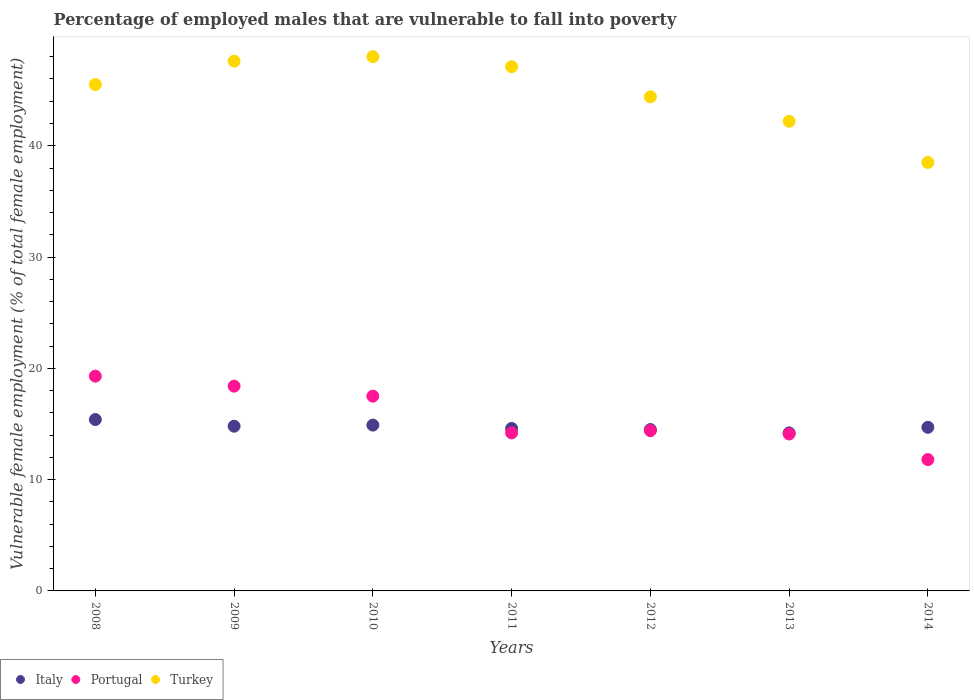What is the percentage of employed males who are vulnerable to fall into poverty in Portugal in 2013?
Give a very brief answer. 14.1. Across all years, what is the maximum percentage of employed males who are vulnerable to fall into poverty in Italy?
Provide a short and direct response. 15.4. Across all years, what is the minimum percentage of employed males who are vulnerable to fall into poverty in Turkey?
Your answer should be very brief. 38.5. What is the total percentage of employed males who are vulnerable to fall into poverty in Italy in the graph?
Your answer should be very brief. 103.1. What is the difference between the percentage of employed males who are vulnerable to fall into poverty in Portugal in 2009 and that in 2014?
Your answer should be very brief. 6.6. What is the difference between the percentage of employed males who are vulnerable to fall into poverty in Turkey in 2014 and the percentage of employed males who are vulnerable to fall into poverty in Italy in 2009?
Ensure brevity in your answer.  23.7. What is the average percentage of employed males who are vulnerable to fall into poverty in Turkey per year?
Provide a succinct answer. 44.76. In the year 2008, what is the difference between the percentage of employed males who are vulnerable to fall into poverty in Italy and percentage of employed males who are vulnerable to fall into poverty in Turkey?
Offer a terse response. -30.1. In how many years, is the percentage of employed males who are vulnerable to fall into poverty in Turkey greater than 20 %?
Keep it short and to the point. 7. What is the ratio of the percentage of employed males who are vulnerable to fall into poverty in Italy in 2010 to that in 2014?
Offer a very short reply. 1.01. What is the difference between the highest and the second highest percentage of employed males who are vulnerable to fall into poverty in Italy?
Keep it short and to the point. 0.5. What is the difference between the highest and the lowest percentage of employed males who are vulnerable to fall into poverty in Italy?
Ensure brevity in your answer.  1.2. Is the percentage of employed males who are vulnerable to fall into poverty in Italy strictly less than the percentage of employed males who are vulnerable to fall into poverty in Turkey over the years?
Offer a terse response. Yes. How many dotlines are there?
Provide a short and direct response. 3. How many years are there in the graph?
Ensure brevity in your answer.  7. What is the difference between two consecutive major ticks on the Y-axis?
Ensure brevity in your answer.  10. Does the graph contain any zero values?
Provide a short and direct response. No. How are the legend labels stacked?
Provide a succinct answer. Horizontal. What is the title of the graph?
Ensure brevity in your answer.  Percentage of employed males that are vulnerable to fall into poverty. Does "Zambia" appear as one of the legend labels in the graph?
Your answer should be compact. No. What is the label or title of the Y-axis?
Your answer should be compact. Vulnerable female employment (% of total female employment). What is the Vulnerable female employment (% of total female employment) in Italy in 2008?
Provide a short and direct response. 15.4. What is the Vulnerable female employment (% of total female employment) of Portugal in 2008?
Your answer should be very brief. 19.3. What is the Vulnerable female employment (% of total female employment) of Turkey in 2008?
Your answer should be compact. 45.5. What is the Vulnerable female employment (% of total female employment) in Italy in 2009?
Give a very brief answer. 14.8. What is the Vulnerable female employment (% of total female employment) in Portugal in 2009?
Give a very brief answer. 18.4. What is the Vulnerable female employment (% of total female employment) in Turkey in 2009?
Offer a very short reply. 47.6. What is the Vulnerable female employment (% of total female employment) of Italy in 2010?
Make the answer very short. 14.9. What is the Vulnerable female employment (% of total female employment) in Portugal in 2010?
Your answer should be compact. 17.5. What is the Vulnerable female employment (% of total female employment) in Italy in 2011?
Give a very brief answer. 14.6. What is the Vulnerable female employment (% of total female employment) of Portugal in 2011?
Offer a very short reply. 14.2. What is the Vulnerable female employment (% of total female employment) of Turkey in 2011?
Offer a terse response. 47.1. What is the Vulnerable female employment (% of total female employment) in Italy in 2012?
Offer a very short reply. 14.5. What is the Vulnerable female employment (% of total female employment) of Portugal in 2012?
Provide a succinct answer. 14.4. What is the Vulnerable female employment (% of total female employment) of Turkey in 2012?
Give a very brief answer. 44.4. What is the Vulnerable female employment (% of total female employment) in Italy in 2013?
Offer a very short reply. 14.2. What is the Vulnerable female employment (% of total female employment) in Portugal in 2013?
Keep it short and to the point. 14.1. What is the Vulnerable female employment (% of total female employment) of Turkey in 2013?
Make the answer very short. 42.2. What is the Vulnerable female employment (% of total female employment) of Italy in 2014?
Provide a succinct answer. 14.7. What is the Vulnerable female employment (% of total female employment) in Portugal in 2014?
Your response must be concise. 11.8. What is the Vulnerable female employment (% of total female employment) of Turkey in 2014?
Provide a succinct answer. 38.5. Across all years, what is the maximum Vulnerable female employment (% of total female employment) in Italy?
Offer a terse response. 15.4. Across all years, what is the maximum Vulnerable female employment (% of total female employment) of Portugal?
Provide a short and direct response. 19.3. Across all years, what is the minimum Vulnerable female employment (% of total female employment) of Italy?
Offer a very short reply. 14.2. Across all years, what is the minimum Vulnerable female employment (% of total female employment) in Portugal?
Keep it short and to the point. 11.8. Across all years, what is the minimum Vulnerable female employment (% of total female employment) in Turkey?
Your answer should be compact. 38.5. What is the total Vulnerable female employment (% of total female employment) in Italy in the graph?
Your answer should be very brief. 103.1. What is the total Vulnerable female employment (% of total female employment) of Portugal in the graph?
Offer a terse response. 109.7. What is the total Vulnerable female employment (% of total female employment) of Turkey in the graph?
Offer a very short reply. 313.3. What is the difference between the Vulnerable female employment (% of total female employment) of Italy in 2008 and that in 2009?
Give a very brief answer. 0.6. What is the difference between the Vulnerable female employment (% of total female employment) of Turkey in 2008 and that in 2009?
Offer a terse response. -2.1. What is the difference between the Vulnerable female employment (% of total female employment) in Italy in 2008 and that in 2010?
Offer a very short reply. 0.5. What is the difference between the Vulnerable female employment (% of total female employment) in Portugal in 2008 and that in 2010?
Your answer should be very brief. 1.8. What is the difference between the Vulnerable female employment (% of total female employment) in Turkey in 2008 and that in 2011?
Make the answer very short. -1.6. What is the difference between the Vulnerable female employment (% of total female employment) of Italy in 2008 and that in 2012?
Offer a terse response. 0.9. What is the difference between the Vulnerable female employment (% of total female employment) of Portugal in 2008 and that in 2012?
Your answer should be very brief. 4.9. What is the difference between the Vulnerable female employment (% of total female employment) of Turkey in 2008 and that in 2012?
Make the answer very short. 1.1. What is the difference between the Vulnerable female employment (% of total female employment) of Italy in 2008 and that in 2013?
Provide a short and direct response. 1.2. What is the difference between the Vulnerable female employment (% of total female employment) of Turkey in 2008 and that in 2013?
Provide a succinct answer. 3.3. What is the difference between the Vulnerable female employment (% of total female employment) of Portugal in 2008 and that in 2014?
Provide a succinct answer. 7.5. What is the difference between the Vulnerable female employment (% of total female employment) in Turkey in 2008 and that in 2014?
Your answer should be compact. 7. What is the difference between the Vulnerable female employment (% of total female employment) in Italy in 2009 and that in 2010?
Give a very brief answer. -0.1. What is the difference between the Vulnerable female employment (% of total female employment) of Portugal in 2009 and that in 2010?
Your response must be concise. 0.9. What is the difference between the Vulnerable female employment (% of total female employment) of Turkey in 2009 and that in 2011?
Provide a succinct answer. 0.5. What is the difference between the Vulnerable female employment (% of total female employment) in Turkey in 2009 and that in 2012?
Provide a short and direct response. 3.2. What is the difference between the Vulnerable female employment (% of total female employment) of Portugal in 2009 and that in 2013?
Provide a short and direct response. 4.3. What is the difference between the Vulnerable female employment (% of total female employment) in Turkey in 2009 and that in 2013?
Offer a very short reply. 5.4. What is the difference between the Vulnerable female employment (% of total female employment) of Italy in 2009 and that in 2014?
Make the answer very short. 0.1. What is the difference between the Vulnerable female employment (% of total female employment) in Portugal in 2009 and that in 2014?
Your response must be concise. 6.6. What is the difference between the Vulnerable female employment (% of total female employment) in Turkey in 2009 and that in 2014?
Ensure brevity in your answer.  9.1. What is the difference between the Vulnerable female employment (% of total female employment) of Italy in 2010 and that in 2011?
Keep it short and to the point. 0.3. What is the difference between the Vulnerable female employment (% of total female employment) of Portugal in 2010 and that in 2011?
Offer a terse response. 3.3. What is the difference between the Vulnerable female employment (% of total female employment) of Turkey in 2010 and that in 2011?
Your answer should be very brief. 0.9. What is the difference between the Vulnerable female employment (% of total female employment) in Portugal in 2010 and that in 2012?
Give a very brief answer. 3.1. What is the difference between the Vulnerable female employment (% of total female employment) in Portugal in 2010 and that in 2013?
Provide a short and direct response. 3.4. What is the difference between the Vulnerable female employment (% of total female employment) of Italy in 2011 and that in 2013?
Provide a succinct answer. 0.4. What is the difference between the Vulnerable female employment (% of total female employment) in Portugal in 2011 and that in 2014?
Your answer should be very brief. 2.4. What is the difference between the Vulnerable female employment (% of total female employment) of Italy in 2012 and that in 2013?
Ensure brevity in your answer.  0.3. What is the difference between the Vulnerable female employment (% of total female employment) in Portugal in 2012 and that in 2013?
Offer a very short reply. 0.3. What is the difference between the Vulnerable female employment (% of total female employment) in Italy in 2012 and that in 2014?
Your answer should be compact. -0.2. What is the difference between the Vulnerable female employment (% of total female employment) in Portugal in 2012 and that in 2014?
Provide a short and direct response. 2.6. What is the difference between the Vulnerable female employment (% of total female employment) in Turkey in 2012 and that in 2014?
Your answer should be very brief. 5.9. What is the difference between the Vulnerable female employment (% of total female employment) in Italy in 2013 and that in 2014?
Make the answer very short. -0.5. What is the difference between the Vulnerable female employment (% of total female employment) of Italy in 2008 and the Vulnerable female employment (% of total female employment) of Turkey in 2009?
Give a very brief answer. -32.2. What is the difference between the Vulnerable female employment (% of total female employment) in Portugal in 2008 and the Vulnerable female employment (% of total female employment) in Turkey in 2009?
Your response must be concise. -28.3. What is the difference between the Vulnerable female employment (% of total female employment) of Italy in 2008 and the Vulnerable female employment (% of total female employment) of Turkey in 2010?
Keep it short and to the point. -32.6. What is the difference between the Vulnerable female employment (% of total female employment) of Portugal in 2008 and the Vulnerable female employment (% of total female employment) of Turkey in 2010?
Your answer should be compact. -28.7. What is the difference between the Vulnerable female employment (% of total female employment) of Italy in 2008 and the Vulnerable female employment (% of total female employment) of Portugal in 2011?
Provide a succinct answer. 1.2. What is the difference between the Vulnerable female employment (% of total female employment) in Italy in 2008 and the Vulnerable female employment (% of total female employment) in Turkey in 2011?
Your response must be concise. -31.7. What is the difference between the Vulnerable female employment (% of total female employment) in Portugal in 2008 and the Vulnerable female employment (% of total female employment) in Turkey in 2011?
Offer a very short reply. -27.8. What is the difference between the Vulnerable female employment (% of total female employment) in Italy in 2008 and the Vulnerable female employment (% of total female employment) in Portugal in 2012?
Offer a very short reply. 1. What is the difference between the Vulnerable female employment (% of total female employment) of Italy in 2008 and the Vulnerable female employment (% of total female employment) of Turkey in 2012?
Your answer should be very brief. -29. What is the difference between the Vulnerable female employment (% of total female employment) of Portugal in 2008 and the Vulnerable female employment (% of total female employment) of Turkey in 2012?
Ensure brevity in your answer.  -25.1. What is the difference between the Vulnerable female employment (% of total female employment) in Italy in 2008 and the Vulnerable female employment (% of total female employment) in Portugal in 2013?
Provide a short and direct response. 1.3. What is the difference between the Vulnerable female employment (% of total female employment) in Italy in 2008 and the Vulnerable female employment (% of total female employment) in Turkey in 2013?
Give a very brief answer. -26.8. What is the difference between the Vulnerable female employment (% of total female employment) in Portugal in 2008 and the Vulnerable female employment (% of total female employment) in Turkey in 2013?
Your answer should be very brief. -22.9. What is the difference between the Vulnerable female employment (% of total female employment) in Italy in 2008 and the Vulnerable female employment (% of total female employment) in Portugal in 2014?
Offer a very short reply. 3.6. What is the difference between the Vulnerable female employment (% of total female employment) in Italy in 2008 and the Vulnerable female employment (% of total female employment) in Turkey in 2014?
Offer a very short reply. -23.1. What is the difference between the Vulnerable female employment (% of total female employment) in Portugal in 2008 and the Vulnerable female employment (% of total female employment) in Turkey in 2014?
Offer a terse response. -19.2. What is the difference between the Vulnerable female employment (% of total female employment) in Italy in 2009 and the Vulnerable female employment (% of total female employment) in Turkey in 2010?
Provide a short and direct response. -33.2. What is the difference between the Vulnerable female employment (% of total female employment) in Portugal in 2009 and the Vulnerable female employment (% of total female employment) in Turkey in 2010?
Offer a very short reply. -29.6. What is the difference between the Vulnerable female employment (% of total female employment) of Italy in 2009 and the Vulnerable female employment (% of total female employment) of Turkey in 2011?
Your answer should be compact. -32.3. What is the difference between the Vulnerable female employment (% of total female employment) of Portugal in 2009 and the Vulnerable female employment (% of total female employment) of Turkey in 2011?
Offer a terse response. -28.7. What is the difference between the Vulnerable female employment (% of total female employment) in Italy in 2009 and the Vulnerable female employment (% of total female employment) in Portugal in 2012?
Your answer should be compact. 0.4. What is the difference between the Vulnerable female employment (% of total female employment) in Italy in 2009 and the Vulnerable female employment (% of total female employment) in Turkey in 2012?
Provide a succinct answer. -29.6. What is the difference between the Vulnerable female employment (% of total female employment) of Italy in 2009 and the Vulnerable female employment (% of total female employment) of Portugal in 2013?
Make the answer very short. 0.7. What is the difference between the Vulnerable female employment (% of total female employment) in Italy in 2009 and the Vulnerable female employment (% of total female employment) in Turkey in 2013?
Your answer should be very brief. -27.4. What is the difference between the Vulnerable female employment (% of total female employment) of Portugal in 2009 and the Vulnerable female employment (% of total female employment) of Turkey in 2013?
Your answer should be compact. -23.8. What is the difference between the Vulnerable female employment (% of total female employment) of Italy in 2009 and the Vulnerable female employment (% of total female employment) of Turkey in 2014?
Your answer should be compact. -23.7. What is the difference between the Vulnerable female employment (% of total female employment) in Portugal in 2009 and the Vulnerable female employment (% of total female employment) in Turkey in 2014?
Keep it short and to the point. -20.1. What is the difference between the Vulnerable female employment (% of total female employment) in Italy in 2010 and the Vulnerable female employment (% of total female employment) in Portugal in 2011?
Give a very brief answer. 0.7. What is the difference between the Vulnerable female employment (% of total female employment) of Italy in 2010 and the Vulnerable female employment (% of total female employment) of Turkey in 2011?
Offer a terse response. -32.2. What is the difference between the Vulnerable female employment (% of total female employment) in Portugal in 2010 and the Vulnerable female employment (% of total female employment) in Turkey in 2011?
Provide a short and direct response. -29.6. What is the difference between the Vulnerable female employment (% of total female employment) of Italy in 2010 and the Vulnerable female employment (% of total female employment) of Turkey in 2012?
Keep it short and to the point. -29.5. What is the difference between the Vulnerable female employment (% of total female employment) in Portugal in 2010 and the Vulnerable female employment (% of total female employment) in Turkey in 2012?
Your answer should be very brief. -26.9. What is the difference between the Vulnerable female employment (% of total female employment) in Italy in 2010 and the Vulnerable female employment (% of total female employment) in Portugal in 2013?
Your response must be concise. 0.8. What is the difference between the Vulnerable female employment (% of total female employment) in Italy in 2010 and the Vulnerable female employment (% of total female employment) in Turkey in 2013?
Your answer should be compact. -27.3. What is the difference between the Vulnerable female employment (% of total female employment) of Portugal in 2010 and the Vulnerable female employment (% of total female employment) of Turkey in 2013?
Provide a succinct answer. -24.7. What is the difference between the Vulnerable female employment (% of total female employment) in Italy in 2010 and the Vulnerable female employment (% of total female employment) in Turkey in 2014?
Provide a succinct answer. -23.6. What is the difference between the Vulnerable female employment (% of total female employment) of Italy in 2011 and the Vulnerable female employment (% of total female employment) of Portugal in 2012?
Provide a short and direct response. 0.2. What is the difference between the Vulnerable female employment (% of total female employment) in Italy in 2011 and the Vulnerable female employment (% of total female employment) in Turkey in 2012?
Provide a succinct answer. -29.8. What is the difference between the Vulnerable female employment (% of total female employment) in Portugal in 2011 and the Vulnerable female employment (% of total female employment) in Turkey in 2012?
Provide a short and direct response. -30.2. What is the difference between the Vulnerable female employment (% of total female employment) in Italy in 2011 and the Vulnerable female employment (% of total female employment) in Turkey in 2013?
Your answer should be compact. -27.6. What is the difference between the Vulnerable female employment (% of total female employment) in Italy in 2011 and the Vulnerable female employment (% of total female employment) in Portugal in 2014?
Provide a succinct answer. 2.8. What is the difference between the Vulnerable female employment (% of total female employment) of Italy in 2011 and the Vulnerable female employment (% of total female employment) of Turkey in 2014?
Give a very brief answer. -23.9. What is the difference between the Vulnerable female employment (% of total female employment) in Portugal in 2011 and the Vulnerable female employment (% of total female employment) in Turkey in 2014?
Offer a terse response. -24.3. What is the difference between the Vulnerable female employment (% of total female employment) of Italy in 2012 and the Vulnerable female employment (% of total female employment) of Portugal in 2013?
Keep it short and to the point. 0.4. What is the difference between the Vulnerable female employment (% of total female employment) of Italy in 2012 and the Vulnerable female employment (% of total female employment) of Turkey in 2013?
Offer a terse response. -27.7. What is the difference between the Vulnerable female employment (% of total female employment) in Portugal in 2012 and the Vulnerable female employment (% of total female employment) in Turkey in 2013?
Your response must be concise. -27.8. What is the difference between the Vulnerable female employment (% of total female employment) of Portugal in 2012 and the Vulnerable female employment (% of total female employment) of Turkey in 2014?
Offer a very short reply. -24.1. What is the difference between the Vulnerable female employment (% of total female employment) of Italy in 2013 and the Vulnerable female employment (% of total female employment) of Turkey in 2014?
Provide a short and direct response. -24.3. What is the difference between the Vulnerable female employment (% of total female employment) in Portugal in 2013 and the Vulnerable female employment (% of total female employment) in Turkey in 2014?
Offer a terse response. -24.4. What is the average Vulnerable female employment (% of total female employment) of Italy per year?
Provide a short and direct response. 14.73. What is the average Vulnerable female employment (% of total female employment) in Portugal per year?
Provide a short and direct response. 15.67. What is the average Vulnerable female employment (% of total female employment) of Turkey per year?
Your answer should be compact. 44.76. In the year 2008, what is the difference between the Vulnerable female employment (% of total female employment) in Italy and Vulnerable female employment (% of total female employment) in Turkey?
Keep it short and to the point. -30.1. In the year 2008, what is the difference between the Vulnerable female employment (% of total female employment) in Portugal and Vulnerable female employment (% of total female employment) in Turkey?
Offer a very short reply. -26.2. In the year 2009, what is the difference between the Vulnerable female employment (% of total female employment) of Italy and Vulnerable female employment (% of total female employment) of Turkey?
Offer a very short reply. -32.8. In the year 2009, what is the difference between the Vulnerable female employment (% of total female employment) of Portugal and Vulnerable female employment (% of total female employment) of Turkey?
Your answer should be very brief. -29.2. In the year 2010, what is the difference between the Vulnerable female employment (% of total female employment) of Italy and Vulnerable female employment (% of total female employment) of Turkey?
Ensure brevity in your answer.  -33.1. In the year 2010, what is the difference between the Vulnerable female employment (% of total female employment) in Portugal and Vulnerable female employment (% of total female employment) in Turkey?
Provide a short and direct response. -30.5. In the year 2011, what is the difference between the Vulnerable female employment (% of total female employment) in Italy and Vulnerable female employment (% of total female employment) in Portugal?
Your answer should be very brief. 0.4. In the year 2011, what is the difference between the Vulnerable female employment (% of total female employment) in Italy and Vulnerable female employment (% of total female employment) in Turkey?
Keep it short and to the point. -32.5. In the year 2011, what is the difference between the Vulnerable female employment (% of total female employment) of Portugal and Vulnerable female employment (% of total female employment) of Turkey?
Make the answer very short. -32.9. In the year 2012, what is the difference between the Vulnerable female employment (% of total female employment) of Italy and Vulnerable female employment (% of total female employment) of Turkey?
Provide a short and direct response. -29.9. In the year 2013, what is the difference between the Vulnerable female employment (% of total female employment) in Italy and Vulnerable female employment (% of total female employment) in Turkey?
Your answer should be very brief. -28. In the year 2013, what is the difference between the Vulnerable female employment (% of total female employment) in Portugal and Vulnerable female employment (% of total female employment) in Turkey?
Your answer should be very brief. -28.1. In the year 2014, what is the difference between the Vulnerable female employment (% of total female employment) of Italy and Vulnerable female employment (% of total female employment) of Portugal?
Keep it short and to the point. 2.9. In the year 2014, what is the difference between the Vulnerable female employment (% of total female employment) in Italy and Vulnerable female employment (% of total female employment) in Turkey?
Keep it short and to the point. -23.8. In the year 2014, what is the difference between the Vulnerable female employment (% of total female employment) in Portugal and Vulnerable female employment (% of total female employment) in Turkey?
Offer a very short reply. -26.7. What is the ratio of the Vulnerable female employment (% of total female employment) of Italy in 2008 to that in 2009?
Your response must be concise. 1.04. What is the ratio of the Vulnerable female employment (% of total female employment) of Portugal in 2008 to that in 2009?
Offer a very short reply. 1.05. What is the ratio of the Vulnerable female employment (% of total female employment) in Turkey in 2008 to that in 2009?
Give a very brief answer. 0.96. What is the ratio of the Vulnerable female employment (% of total female employment) in Italy in 2008 to that in 2010?
Provide a succinct answer. 1.03. What is the ratio of the Vulnerable female employment (% of total female employment) of Portugal in 2008 to that in 2010?
Offer a terse response. 1.1. What is the ratio of the Vulnerable female employment (% of total female employment) in Turkey in 2008 to that in 2010?
Give a very brief answer. 0.95. What is the ratio of the Vulnerable female employment (% of total female employment) of Italy in 2008 to that in 2011?
Offer a terse response. 1.05. What is the ratio of the Vulnerable female employment (% of total female employment) of Portugal in 2008 to that in 2011?
Ensure brevity in your answer.  1.36. What is the ratio of the Vulnerable female employment (% of total female employment) of Turkey in 2008 to that in 2011?
Make the answer very short. 0.97. What is the ratio of the Vulnerable female employment (% of total female employment) in Italy in 2008 to that in 2012?
Ensure brevity in your answer.  1.06. What is the ratio of the Vulnerable female employment (% of total female employment) of Portugal in 2008 to that in 2012?
Give a very brief answer. 1.34. What is the ratio of the Vulnerable female employment (% of total female employment) of Turkey in 2008 to that in 2012?
Your response must be concise. 1.02. What is the ratio of the Vulnerable female employment (% of total female employment) of Italy in 2008 to that in 2013?
Give a very brief answer. 1.08. What is the ratio of the Vulnerable female employment (% of total female employment) in Portugal in 2008 to that in 2013?
Offer a very short reply. 1.37. What is the ratio of the Vulnerable female employment (% of total female employment) of Turkey in 2008 to that in 2013?
Provide a succinct answer. 1.08. What is the ratio of the Vulnerable female employment (% of total female employment) of Italy in 2008 to that in 2014?
Your response must be concise. 1.05. What is the ratio of the Vulnerable female employment (% of total female employment) of Portugal in 2008 to that in 2014?
Offer a very short reply. 1.64. What is the ratio of the Vulnerable female employment (% of total female employment) of Turkey in 2008 to that in 2014?
Make the answer very short. 1.18. What is the ratio of the Vulnerable female employment (% of total female employment) in Italy in 2009 to that in 2010?
Give a very brief answer. 0.99. What is the ratio of the Vulnerable female employment (% of total female employment) in Portugal in 2009 to that in 2010?
Make the answer very short. 1.05. What is the ratio of the Vulnerable female employment (% of total female employment) of Turkey in 2009 to that in 2010?
Give a very brief answer. 0.99. What is the ratio of the Vulnerable female employment (% of total female employment) of Italy in 2009 to that in 2011?
Offer a terse response. 1.01. What is the ratio of the Vulnerable female employment (% of total female employment) of Portugal in 2009 to that in 2011?
Provide a succinct answer. 1.3. What is the ratio of the Vulnerable female employment (% of total female employment) in Turkey in 2009 to that in 2011?
Ensure brevity in your answer.  1.01. What is the ratio of the Vulnerable female employment (% of total female employment) in Italy in 2009 to that in 2012?
Provide a succinct answer. 1.02. What is the ratio of the Vulnerable female employment (% of total female employment) of Portugal in 2009 to that in 2012?
Give a very brief answer. 1.28. What is the ratio of the Vulnerable female employment (% of total female employment) in Turkey in 2009 to that in 2012?
Your answer should be very brief. 1.07. What is the ratio of the Vulnerable female employment (% of total female employment) in Italy in 2009 to that in 2013?
Offer a very short reply. 1.04. What is the ratio of the Vulnerable female employment (% of total female employment) in Portugal in 2009 to that in 2013?
Give a very brief answer. 1.3. What is the ratio of the Vulnerable female employment (% of total female employment) of Turkey in 2009 to that in 2013?
Your answer should be very brief. 1.13. What is the ratio of the Vulnerable female employment (% of total female employment) in Italy in 2009 to that in 2014?
Offer a terse response. 1.01. What is the ratio of the Vulnerable female employment (% of total female employment) in Portugal in 2009 to that in 2014?
Keep it short and to the point. 1.56. What is the ratio of the Vulnerable female employment (% of total female employment) in Turkey in 2009 to that in 2014?
Your answer should be very brief. 1.24. What is the ratio of the Vulnerable female employment (% of total female employment) in Italy in 2010 to that in 2011?
Offer a terse response. 1.02. What is the ratio of the Vulnerable female employment (% of total female employment) in Portugal in 2010 to that in 2011?
Your response must be concise. 1.23. What is the ratio of the Vulnerable female employment (% of total female employment) in Turkey in 2010 to that in 2011?
Make the answer very short. 1.02. What is the ratio of the Vulnerable female employment (% of total female employment) in Italy in 2010 to that in 2012?
Keep it short and to the point. 1.03. What is the ratio of the Vulnerable female employment (% of total female employment) in Portugal in 2010 to that in 2012?
Ensure brevity in your answer.  1.22. What is the ratio of the Vulnerable female employment (% of total female employment) in Turkey in 2010 to that in 2012?
Offer a terse response. 1.08. What is the ratio of the Vulnerable female employment (% of total female employment) of Italy in 2010 to that in 2013?
Give a very brief answer. 1.05. What is the ratio of the Vulnerable female employment (% of total female employment) of Portugal in 2010 to that in 2013?
Provide a short and direct response. 1.24. What is the ratio of the Vulnerable female employment (% of total female employment) of Turkey in 2010 to that in 2013?
Offer a very short reply. 1.14. What is the ratio of the Vulnerable female employment (% of total female employment) in Italy in 2010 to that in 2014?
Offer a very short reply. 1.01. What is the ratio of the Vulnerable female employment (% of total female employment) in Portugal in 2010 to that in 2014?
Your response must be concise. 1.48. What is the ratio of the Vulnerable female employment (% of total female employment) of Turkey in 2010 to that in 2014?
Provide a succinct answer. 1.25. What is the ratio of the Vulnerable female employment (% of total female employment) in Italy in 2011 to that in 2012?
Your answer should be compact. 1.01. What is the ratio of the Vulnerable female employment (% of total female employment) in Portugal in 2011 to that in 2012?
Give a very brief answer. 0.99. What is the ratio of the Vulnerable female employment (% of total female employment) of Turkey in 2011 to that in 2012?
Offer a very short reply. 1.06. What is the ratio of the Vulnerable female employment (% of total female employment) of Italy in 2011 to that in 2013?
Provide a short and direct response. 1.03. What is the ratio of the Vulnerable female employment (% of total female employment) in Portugal in 2011 to that in 2013?
Provide a succinct answer. 1.01. What is the ratio of the Vulnerable female employment (% of total female employment) in Turkey in 2011 to that in 2013?
Provide a short and direct response. 1.12. What is the ratio of the Vulnerable female employment (% of total female employment) in Portugal in 2011 to that in 2014?
Provide a short and direct response. 1.2. What is the ratio of the Vulnerable female employment (% of total female employment) in Turkey in 2011 to that in 2014?
Provide a short and direct response. 1.22. What is the ratio of the Vulnerable female employment (% of total female employment) of Italy in 2012 to that in 2013?
Your answer should be compact. 1.02. What is the ratio of the Vulnerable female employment (% of total female employment) of Portugal in 2012 to that in 2013?
Provide a short and direct response. 1.02. What is the ratio of the Vulnerable female employment (% of total female employment) of Turkey in 2012 to that in 2013?
Provide a succinct answer. 1.05. What is the ratio of the Vulnerable female employment (% of total female employment) in Italy in 2012 to that in 2014?
Make the answer very short. 0.99. What is the ratio of the Vulnerable female employment (% of total female employment) in Portugal in 2012 to that in 2014?
Offer a very short reply. 1.22. What is the ratio of the Vulnerable female employment (% of total female employment) in Turkey in 2012 to that in 2014?
Your answer should be very brief. 1.15. What is the ratio of the Vulnerable female employment (% of total female employment) of Portugal in 2013 to that in 2014?
Your answer should be compact. 1.19. What is the ratio of the Vulnerable female employment (% of total female employment) of Turkey in 2013 to that in 2014?
Provide a short and direct response. 1.1. What is the difference between the highest and the second highest Vulnerable female employment (% of total female employment) of Portugal?
Keep it short and to the point. 0.9. What is the difference between the highest and the second highest Vulnerable female employment (% of total female employment) of Turkey?
Your answer should be very brief. 0.4. What is the difference between the highest and the lowest Vulnerable female employment (% of total female employment) of Turkey?
Your answer should be compact. 9.5. 